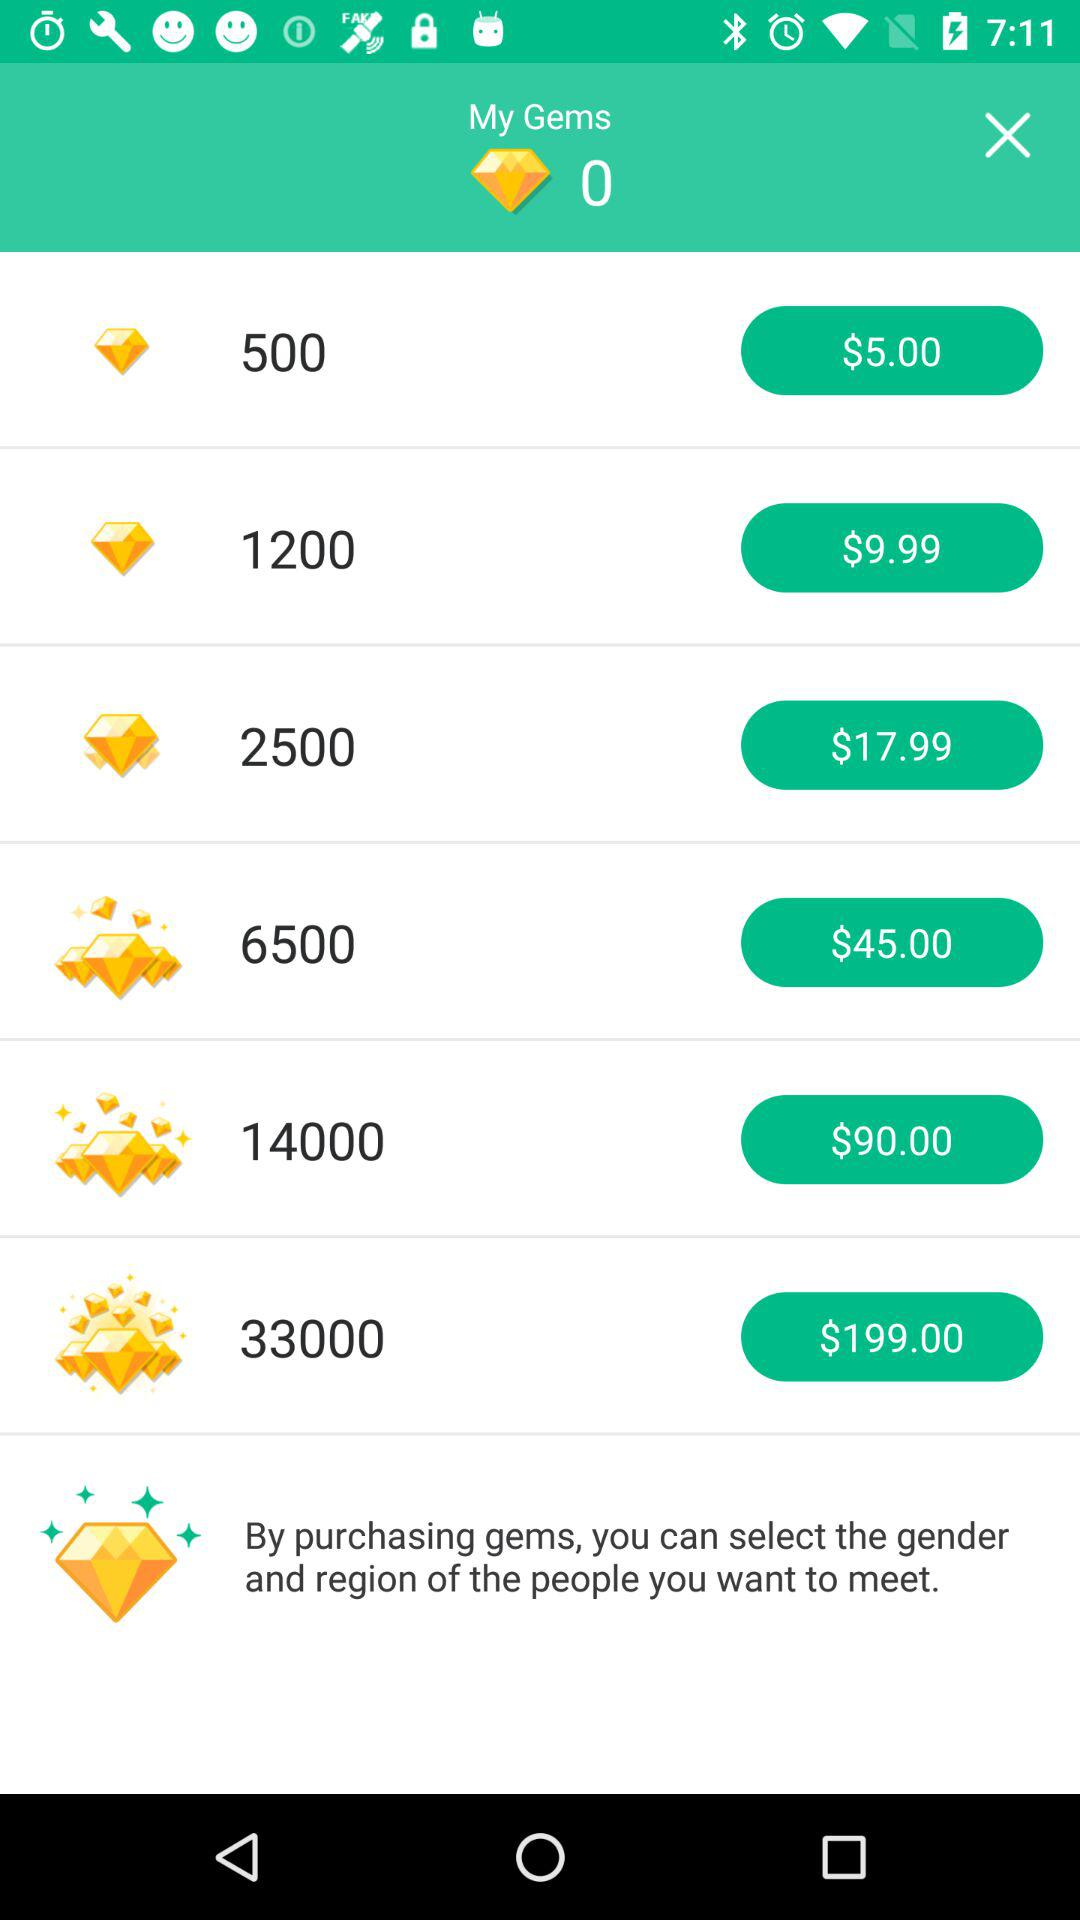How many gems are in "My Gems"? There are 0 gems in "My Gems". 